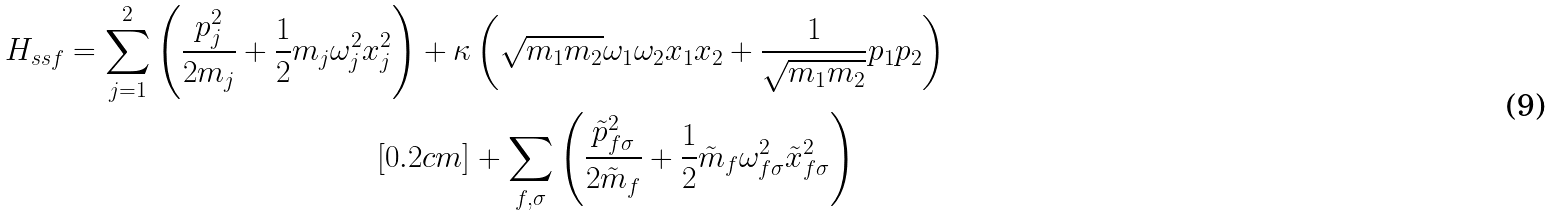<formula> <loc_0><loc_0><loc_500><loc_500>H _ { s s f } = \sum _ { j = 1 } ^ { 2 } \left ( \frac { p _ { j } ^ { 2 } } { 2 m _ { j } } + \frac { 1 } { 2 } m _ { j } \omega _ { j } ^ { 2 } x _ { j } ^ { 2 } \right ) + \kappa & \left ( \sqrt { m _ { 1 } m _ { 2 } } \omega _ { 1 } \omega _ { 2 } x _ { 1 } x _ { 2 } + \frac { 1 } { \sqrt { m _ { 1 } m _ { 2 } } } p _ { 1 } p _ { 2 } \right ) \\ [ 0 . 2 c m ] & + \sum _ { f , \sigma } \left ( \frac { \tilde { p } _ { f \sigma } ^ { 2 } } { 2 \tilde { m } _ { f } } + \frac { 1 } { 2 } \tilde { m } _ { f } \omega _ { f \sigma } ^ { 2 } \tilde { x } _ { f \sigma } ^ { 2 } \right )</formula> 